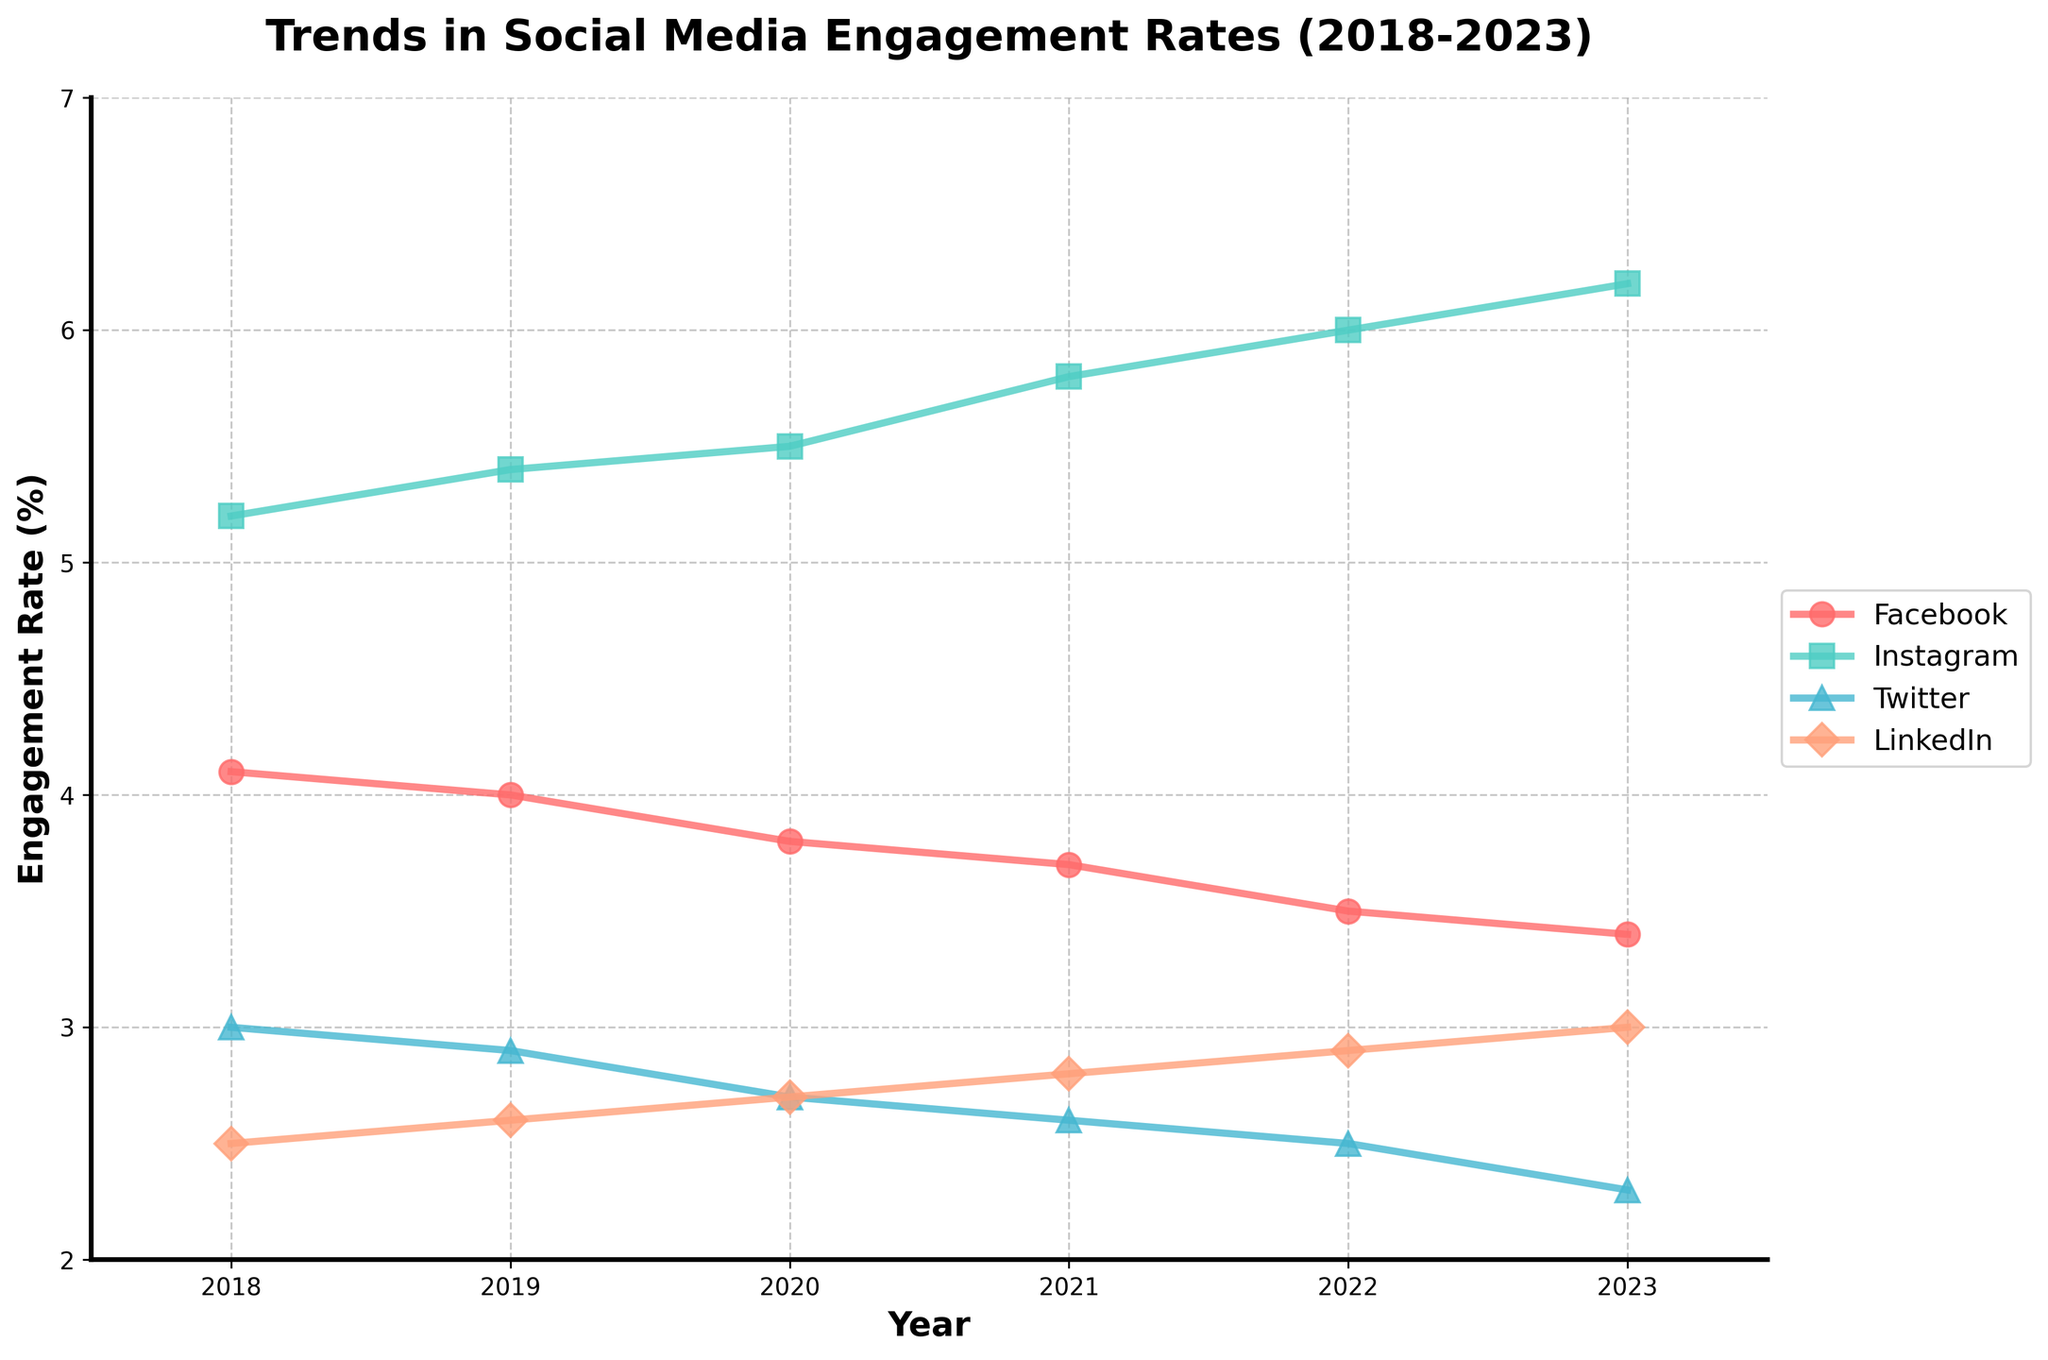What is the title of the figure? The title is located at the top of the figure and describes what the plot is about. It reads as follows: 'Trends in Social Media Engagement Rates (2018-2023)'.
Answer: Trends in Social Media Engagement Rates (2018-2023) Which platform had the highest engagement rate in 2023? To determine this, look at the engagement rates for all platforms in 2023 and find the highest value. Instagram shows the highest engagement rate at 6.2% in 2023.
Answer: Instagram What is the range of engagement rates for LinkedIn from 2018 to 2023? To find the range, identify the highest and lowest engagement rates for LinkedIn over the specified years. The highest is 3.0 in 2023, and the lowest is 2.5 in 2018. The range is 3.0 - 2.5.
Answer: 0.5 By how much did Facebook's engagement rate decrease from 2018 to 2023? Subtract Facebook's engagement rate in 2023 from its rate in 2018. The engagement rate decreased from 4.1% to 3.4%, so the decrease is 4.1 - 3.4.
Answer: 0.7% Which platform had a consistent increase in engagement rate from 2018 to 2023? Observe the trends for each platform. Instagram shows a consistent increase from 5.2% in 2018 to 6.2% in 2023 without any decreases.
Answer: Instagram What's the average engagement rate for Twitter from 2018 to 2023? Add the engagement rates for Twitter over the five years and then divide by the number of years (5). The rates are 3.0, 2.9, 2.7, 2.6, and 2.3. Sum is 14.5, and average is 14.5 / 5.
Answer: 2.9% Which platform had the smallest change in engagement rate over the five years? Compare the differences between the highest and lowest engagement rates for each platform. LinkedIn had the smallest change, with rates ranging only from 2.5% to 3.0%.
Answer: LinkedIn In which year did Instagram have the highest year-on-year increase in engagement rate? Calculate the year-on-year changes for Instagram and find the largest. From the data, the largest increase is from 2020 to 2021, from 5.5% to 5.8%.
Answer: 2021 How does the engagement rate trend of LinkedIn compare to that of Twitter? Evaluate the trends from 2018 to 2023 for both platforms. LinkedIn shows a slightly increasing trend, whereas Twitter shows a consistently decreasing trend.
Answer: LinkedIn increases, Twitter decreases 